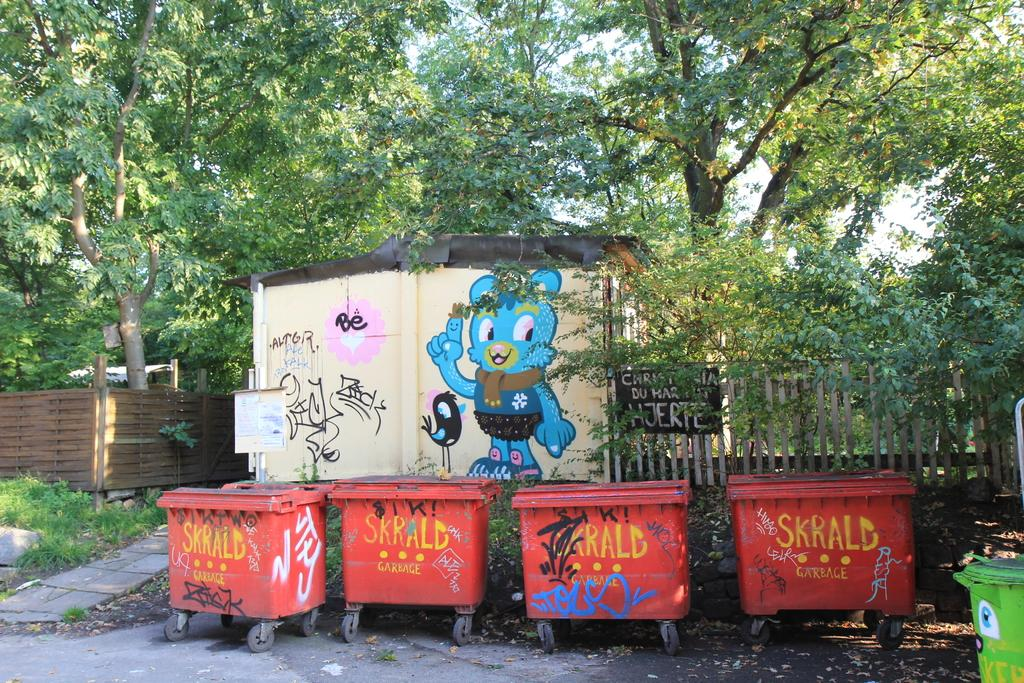<image>
Summarize the visual content of the image. Four dumpsters that say skrald on them sit near a graffiti wall. 